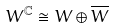Convert formula to latex. <formula><loc_0><loc_0><loc_500><loc_500>W ^ { \mathbb { C } } \cong W \oplus \overline { W }</formula> 